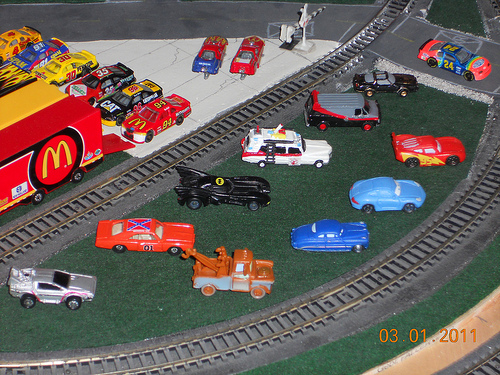<image>
Is there a railway track under the car? No. The railway track is not positioned under the car. The vertical relationship between these objects is different. Is there a racecar toy in front of the railroad crossing? No. The racecar toy is not in front of the railroad crossing. The spatial positioning shows a different relationship between these objects. 